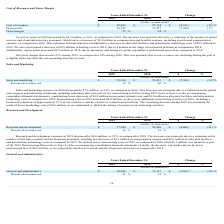According to Marin Software's financial document, What is the company's decrease in sales and marketing expenses between 2018 and 2019? According to the financial document, $7.6 million. The relevant text states: "Sales and marketing expenses in 2019 decreased by $7.6 million, or 32%, as compared to 2018. This decrease was primarily due to a reduction in the global..." Also, What is the difference in the company's 2019 personnel-related costs as compared to 2018? According to the financial document, $4.8 million. The relevant text states: "cial statements), contributing to net decreases of $4.8 million in personnel-related costs, and $1.0 million in allocated facilities and information technology cost..." Also, What is the company's respective sales and marketing expenses in 2019 and 2018 as a percentage of its revenue? The document shows two values: 32% and 40%. From the document: "Sales and marketing $ 15,836 $ 23,425 $ (7,589) (32) % Percent of revenues, net 32 % 40 %..." Also, can you calculate: What is the company's average sales and marketing expenses in 2018 and 2019? To answer this question, I need to perform calculations using the financial data. The calculation is: (15,836 + 23,425)/2 , which equals 19630.5 (in thousands). This is based on the information: "Sales and marketing $ 15,836 $ 23,425 $ (7,589) (32) % Sales and marketing $ 15,836 $ 23,425 $ (7,589) (32) %..." The key data points involved are: 15,836, 23,425. Also, can you calculate: What is the value of the change between 2018 and 2019's sales and marketing expenses as a percentage of the 2018 sales and marketing expenses? Based on the calculation: 7,589/23,425 , the result is 32.4 (percentage). This is based on the information: "Sales and marketing $ 15,836 $ 23,425 $ (7,589) (32) % Sales and marketing $ 15,836 $ 23,425 $ (7,589) (32) %..." The key data points involved are: 23,425, 7,589. Also, can you calculate: What is the value of the change in 2018 and 2019's sales and marketing expenses as a percentage of the 2019 sales and marketing expenses? Based on the calculation: 7,589/15,836 , the result is 47.92 (percentage). This is based on the information: "Sales and marketing $ 15,836 $ 23,425 $ (7,589) (32) % Sales and marketing $ 15,836 $ 23,425 $ (7,589) (32) %..." The key data points involved are: 15,836, 7,589. 